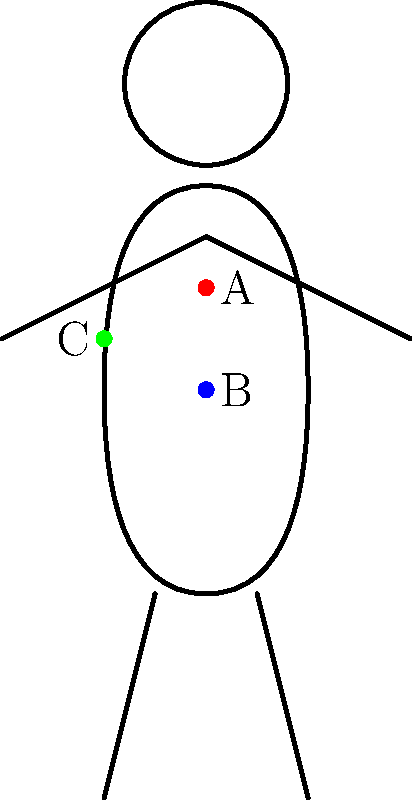Which hand placement(s) on the human figure outline would be most effective for feeling vibrations during vocalization for singers with hearing impairments? To determine the most effective hand placement(s) for feeling vibrations during vocalization, we need to consider the following steps:

1. Understand the anatomy of vocal vibrations:
   - Vibrations originate in the larynx (voice box) and resonate through the vocal tract.
   - The strongest vibrations are typically felt near the source and in resonating cavities.

2. Analyze the hand placements shown in the figure:
   - Point A: Located at the throat, directly over the larynx.
   - Point B: Positioned on the upper chest.
   - Point C: Placed on the side of the neck.

3. Evaluate each placement:
   - Point A (throat): This is directly over the larynx, where vibrations are strongest and most immediate. It allows for direct feedback on vocal cord vibration.
   - Point B (chest): The chest acts as a resonating cavity, especially for lower frequencies. It can provide information on resonance and breath support.
   - Point C (side of neck): This area allows for feeling vibrations from both the larynx and the pharynx, providing information on both source and resonance.

4. Consider the effectiveness for singers with hearing impairments:
   - Direct feedback is crucial for those who cannot rely on auditory cues.
   - Multiple points of contact can provide more comprehensive information about the voice.

5. Conclusion:
   All three placements offer valuable feedback, but A and C are particularly effective due to their proximity to the vibration source and resonating areas.
Answer: A and C 